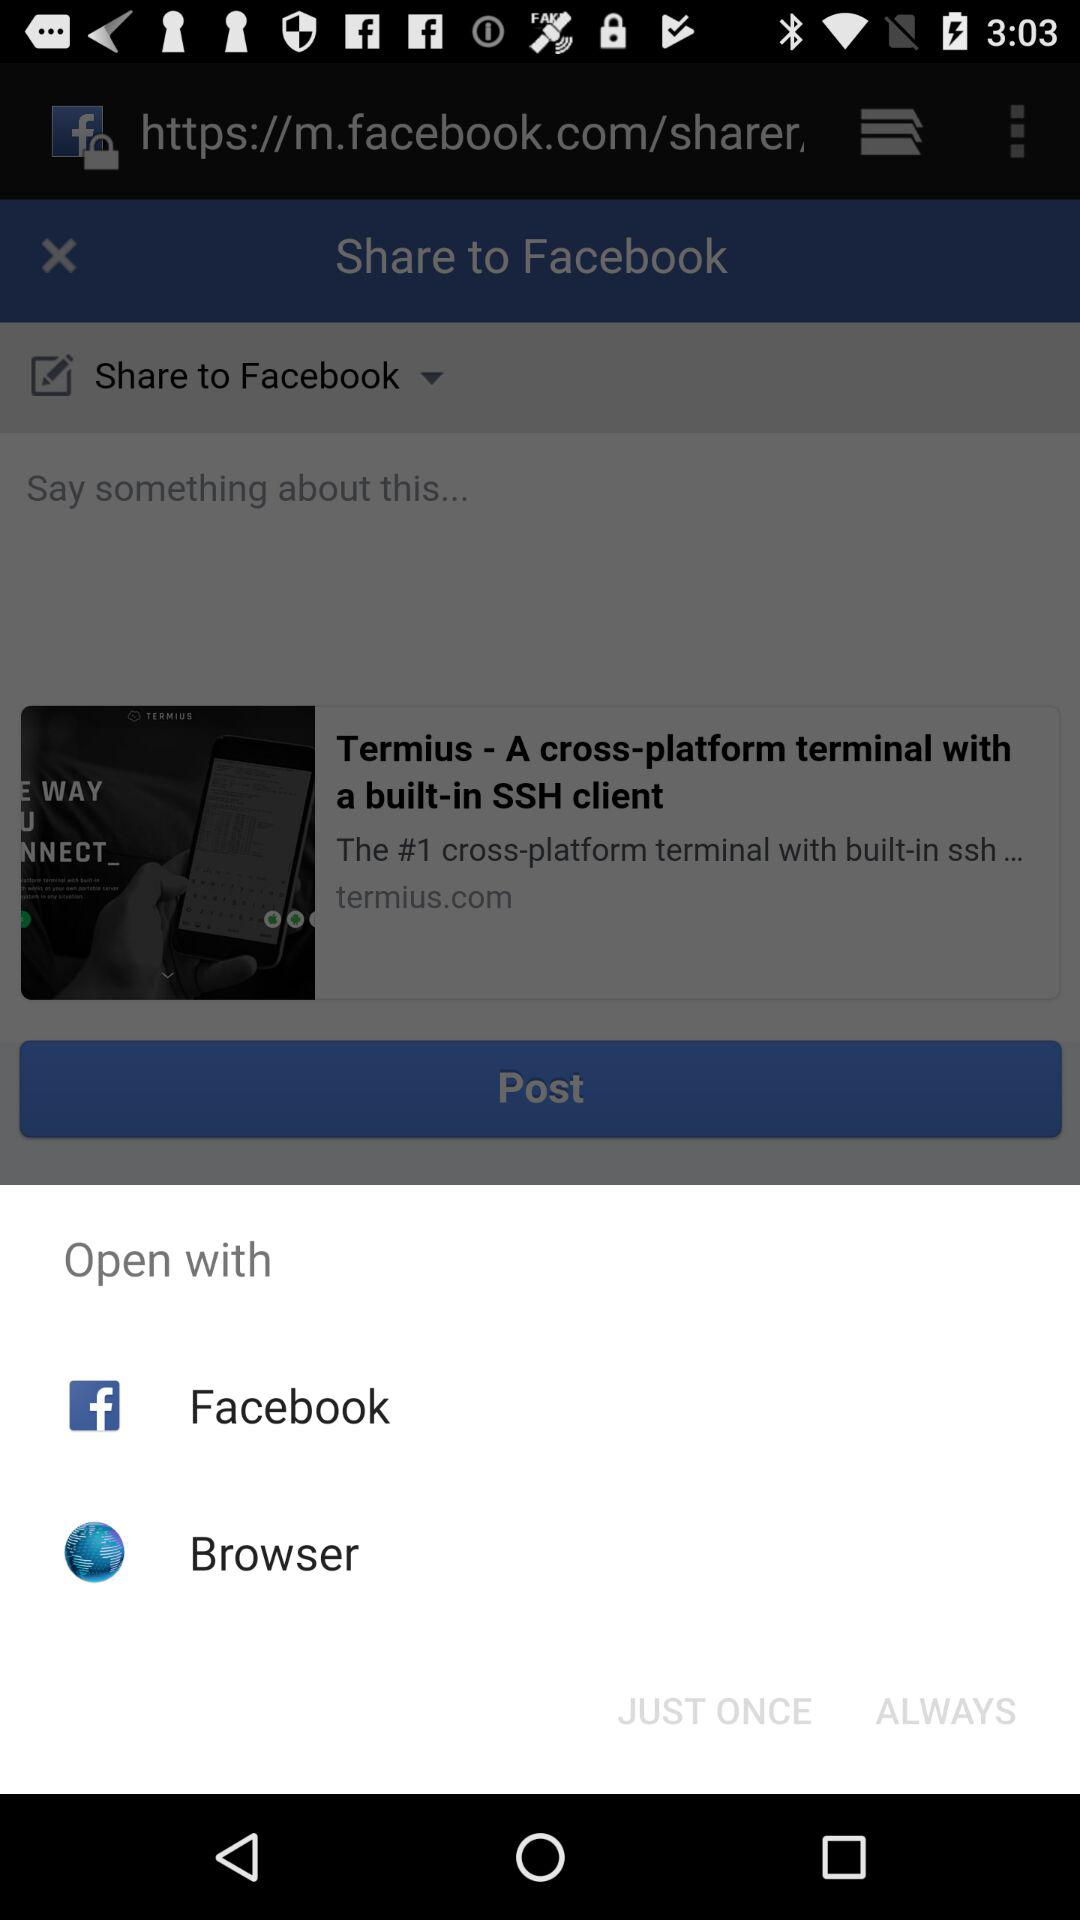Which application can I use to open the content? You can use the "Facebook" and "Browser" applications to open the content. 